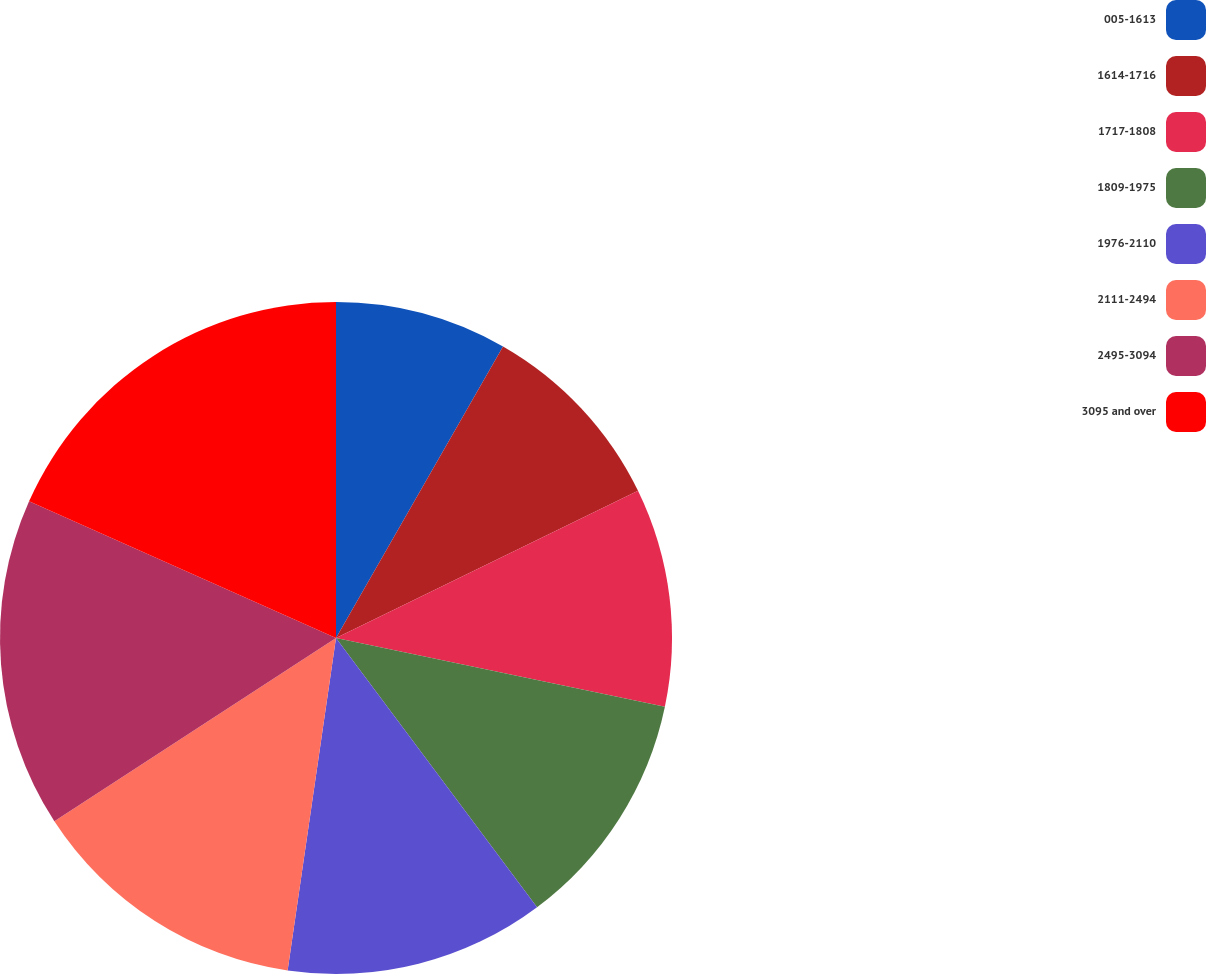<chart> <loc_0><loc_0><loc_500><loc_500><pie_chart><fcel>005-1613<fcel>1614-1716<fcel>1717-1808<fcel>1809-1975<fcel>1976-2110<fcel>2111-2494<fcel>2495-3094<fcel>3095 and over<nl><fcel>8.28%<fcel>9.5%<fcel>10.5%<fcel>11.51%<fcel>12.51%<fcel>13.52%<fcel>15.85%<fcel>18.33%<nl></chart> 